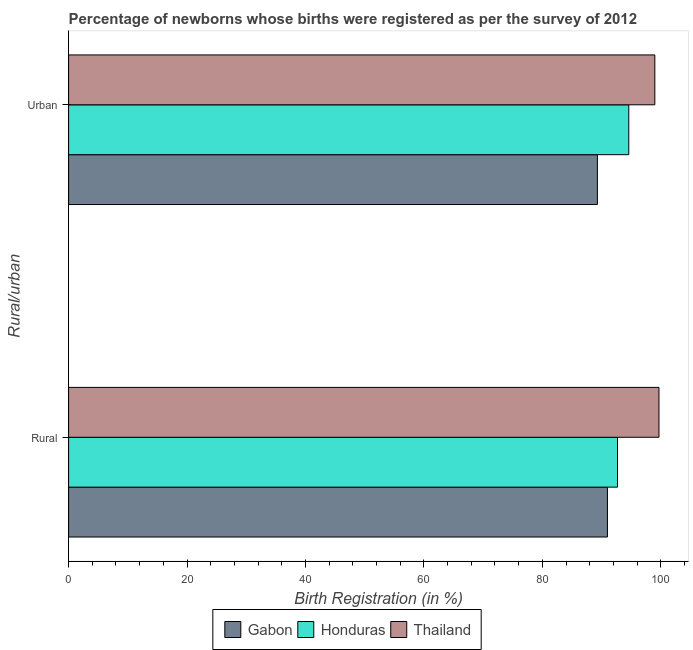How many different coloured bars are there?
Make the answer very short. 3. How many groups of bars are there?
Your response must be concise. 2. Are the number of bars per tick equal to the number of legend labels?
Your answer should be compact. Yes. Are the number of bars on each tick of the Y-axis equal?
Provide a succinct answer. Yes. How many bars are there on the 2nd tick from the bottom?
Offer a very short reply. 3. What is the label of the 1st group of bars from the top?
Ensure brevity in your answer.  Urban. What is the rural birth registration in Gabon?
Provide a short and direct response. 91. Across all countries, what is the maximum rural birth registration?
Your response must be concise. 99.7. Across all countries, what is the minimum rural birth registration?
Give a very brief answer. 91. In which country was the urban birth registration maximum?
Ensure brevity in your answer.  Thailand. In which country was the urban birth registration minimum?
Your response must be concise. Gabon. What is the total urban birth registration in the graph?
Make the answer very short. 282.9. What is the difference between the rural birth registration in Gabon and that in Honduras?
Provide a short and direct response. -1.7. What is the difference between the rural birth registration in Gabon and the urban birth registration in Honduras?
Provide a succinct answer. -3.6. What is the average urban birth registration per country?
Offer a very short reply. 94.3. What is the difference between the rural birth registration and urban birth registration in Gabon?
Ensure brevity in your answer.  1.7. What is the ratio of the rural birth registration in Gabon to that in Thailand?
Give a very brief answer. 0.91. What does the 2nd bar from the top in Urban represents?
Offer a terse response. Honduras. What does the 1st bar from the bottom in Rural represents?
Your answer should be very brief. Gabon. How many bars are there?
Offer a terse response. 6. How many countries are there in the graph?
Your answer should be very brief. 3. How many legend labels are there?
Keep it short and to the point. 3. What is the title of the graph?
Provide a succinct answer. Percentage of newborns whose births were registered as per the survey of 2012. What is the label or title of the X-axis?
Keep it short and to the point. Birth Registration (in %). What is the label or title of the Y-axis?
Make the answer very short. Rural/urban. What is the Birth Registration (in %) in Gabon in Rural?
Your answer should be very brief. 91. What is the Birth Registration (in %) of Honduras in Rural?
Ensure brevity in your answer.  92.7. What is the Birth Registration (in %) of Thailand in Rural?
Your answer should be compact. 99.7. What is the Birth Registration (in %) of Gabon in Urban?
Ensure brevity in your answer.  89.3. What is the Birth Registration (in %) in Honduras in Urban?
Offer a terse response. 94.6. What is the Birth Registration (in %) of Thailand in Urban?
Offer a terse response. 99. Across all Rural/urban, what is the maximum Birth Registration (in %) in Gabon?
Offer a terse response. 91. Across all Rural/urban, what is the maximum Birth Registration (in %) in Honduras?
Your answer should be very brief. 94.6. Across all Rural/urban, what is the maximum Birth Registration (in %) in Thailand?
Provide a short and direct response. 99.7. Across all Rural/urban, what is the minimum Birth Registration (in %) of Gabon?
Make the answer very short. 89.3. Across all Rural/urban, what is the minimum Birth Registration (in %) in Honduras?
Your answer should be compact. 92.7. Across all Rural/urban, what is the minimum Birth Registration (in %) in Thailand?
Your answer should be very brief. 99. What is the total Birth Registration (in %) in Gabon in the graph?
Give a very brief answer. 180.3. What is the total Birth Registration (in %) in Honduras in the graph?
Ensure brevity in your answer.  187.3. What is the total Birth Registration (in %) of Thailand in the graph?
Offer a terse response. 198.7. What is the difference between the Birth Registration (in %) in Honduras in Rural and that in Urban?
Ensure brevity in your answer.  -1.9. What is the difference between the Birth Registration (in %) of Thailand in Rural and that in Urban?
Make the answer very short. 0.7. What is the difference between the Birth Registration (in %) in Gabon in Rural and the Birth Registration (in %) in Honduras in Urban?
Keep it short and to the point. -3.6. What is the difference between the Birth Registration (in %) of Honduras in Rural and the Birth Registration (in %) of Thailand in Urban?
Keep it short and to the point. -6.3. What is the average Birth Registration (in %) of Gabon per Rural/urban?
Provide a succinct answer. 90.15. What is the average Birth Registration (in %) in Honduras per Rural/urban?
Your answer should be very brief. 93.65. What is the average Birth Registration (in %) in Thailand per Rural/urban?
Provide a succinct answer. 99.35. What is the difference between the Birth Registration (in %) in Gabon and Birth Registration (in %) in Honduras in Rural?
Provide a succinct answer. -1.7. What is the difference between the Birth Registration (in %) in Gabon and Birth Registration (in %) in Thailand in Urban?
Offer a very short reply. -9.7. What is the difference between the Birth Registration (in %) in Honduras and Birth Registration (in %) in Thailand in Urban?
Offer a very short reply. -4.4. What is the ratio of the Birth Registration (in %) in Gabon in Rural to that in Urban?
Keep it short and to the point. 1.02. What is the ratio of the Birth Registration (in %) in Honduras in Rural to that in Urban?
Your answer should be compact. 0.98. What is the ratio of the Birth Registration (in %) in Thailand in Rural to that in Urban?
Provide a short and direct response. 1.01. What is the difference between the highest and the second highest Birth Registration (in %) of Gabon?
Your response must be concise. 1.7. What is the difference between the highest and the lowest Birth Registration (in %) of Thailand?
Your answer should be very brief. 0.7. 